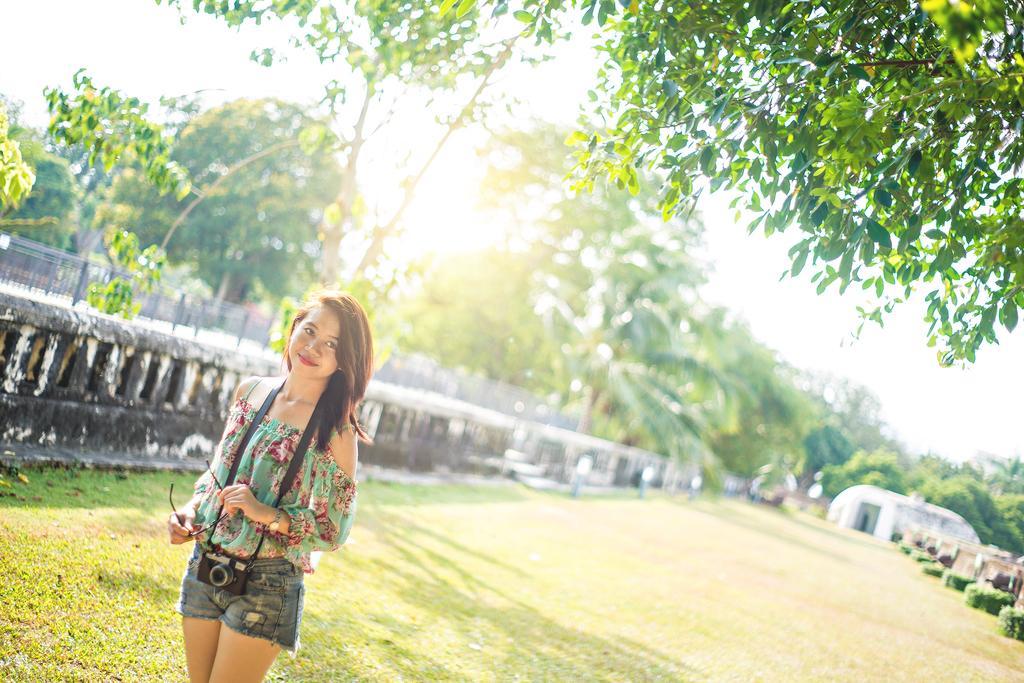In one or two sentences, can you explain what this image depicts? In this image there is a girl holding specks in her hand and she is wearing a camera on her neck, she is standing on the surface of the grass. On the left side of the image there is a fencing with wall. At the top of the image we can see the leaves of a tree. In the background there are trees and the sky. 